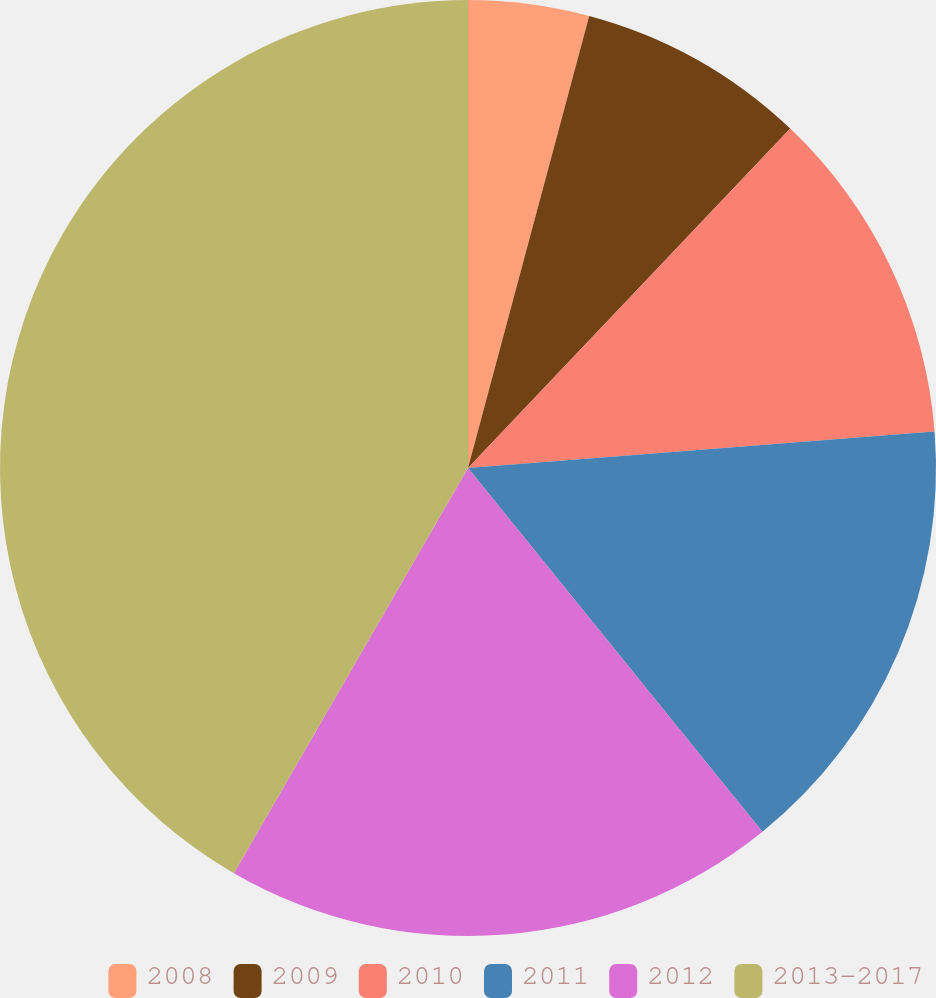Convert chart to OTSL. <chart><loc_0><loc_0><loc_500><loc_500><pie_chart><fcel>2008<fcel>2009<fcel>2010<fcel>2011<fcel>2012<fcel>2013-2017<nl><fcel>4.17%<fcel>7.92%<fcel>11.67%<fcel>15.42%<fcel>19.17%<fcel>41.67%<nl></chart> 